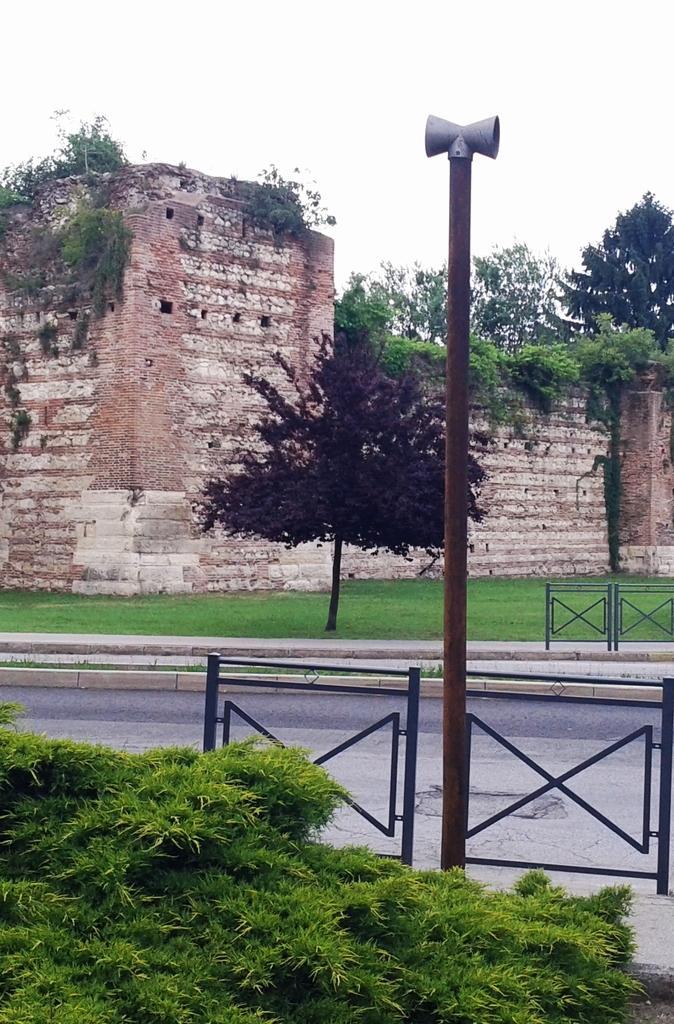Can you describe this image briefly? In this image, in the middle, we can see a metal rod. In the left corner, we can see some grass. In the background, we can see metal grill, trees, building, wall, plants. At the top, we can see a sky, at the bottom, we can see a grass and a road. 